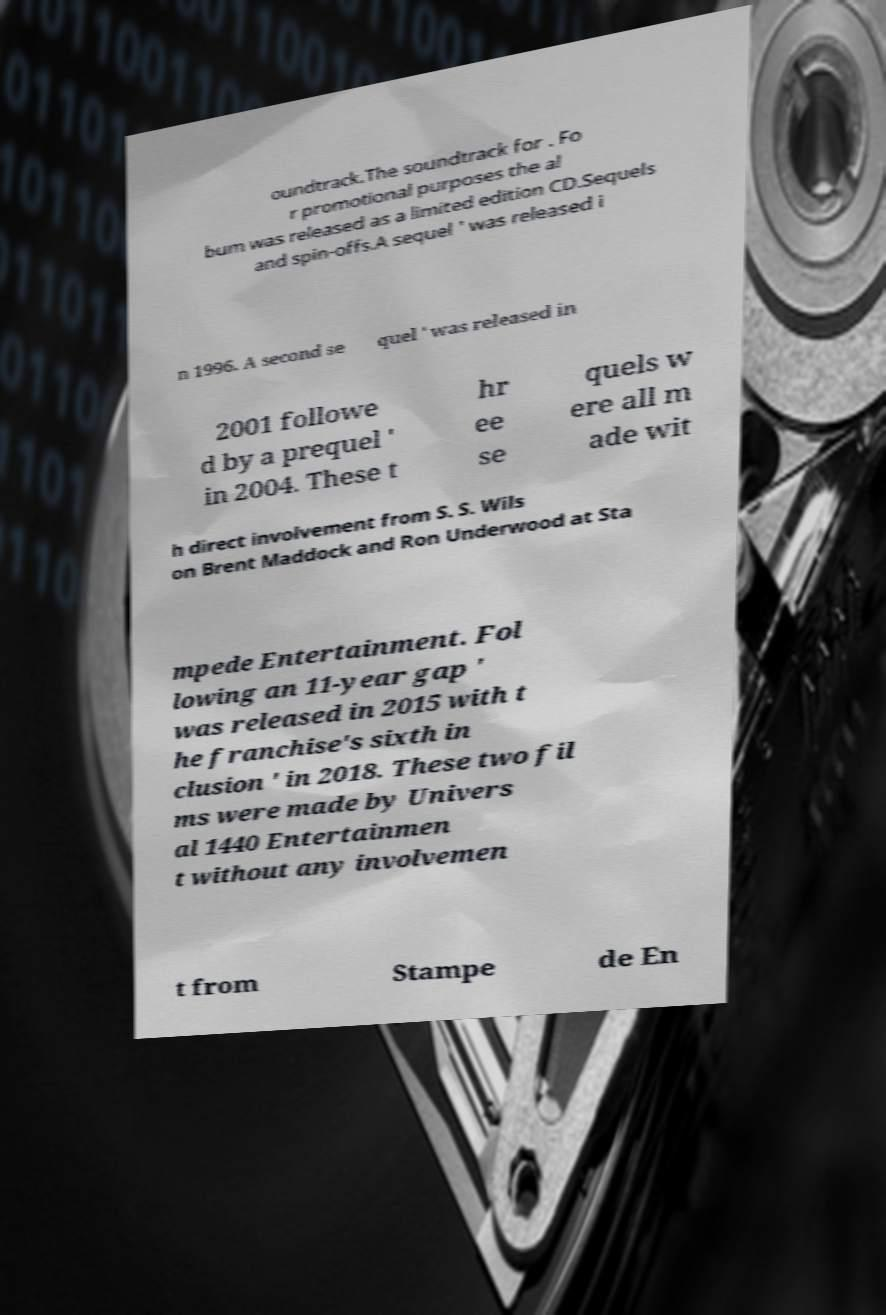Can you read and provide the text displayed in the image?This photo seems to have some interesting text. Can you extract and type it out for me? oundtrack.The soundtrack for . Fo r promotional purposes the al bum was released as a limited edition CD.Sequels and spin-offs.A sequel ' was released i n 1996. A second se quel ' was released in 2001 followe d by a prequel ' in 2004. These t hr ee se quels w ere all m ade wit h direct involvement from S. S. Wils on Brent Maddock and Ron Underwood at Sta mpede Entertainment. Fol lowing an 11-year gap ' was released in 2015 with t he franchise's sixth in clusion ' in 2018. These two fil ms were made by Univers al 1440 Entertainmen t without any involvemen t from Stampe de En 